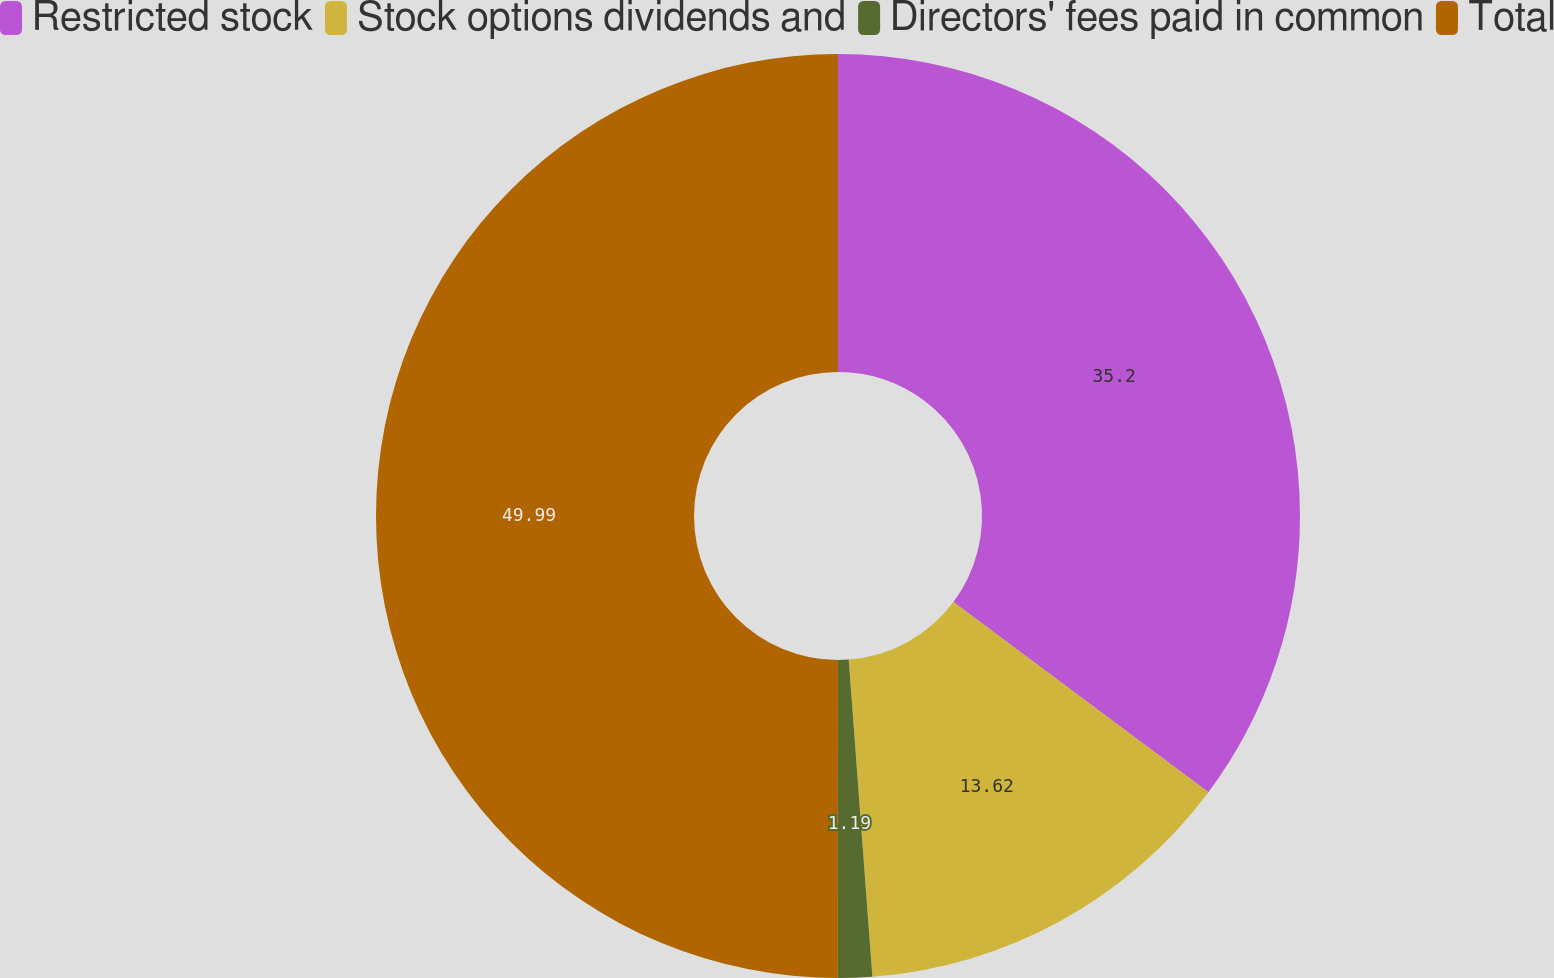<chart> <loc_0><loc_0><loc_500><loc_500><pie_chart><fcel>Restricted stock<fcel>Stock options dividends and<fcel>Directors' fees paid in common<fcel>Total<nl><fcel>35.2%<fcel>13.62%<fcel>1.19%<fcel>50.0%<nl></chart> 